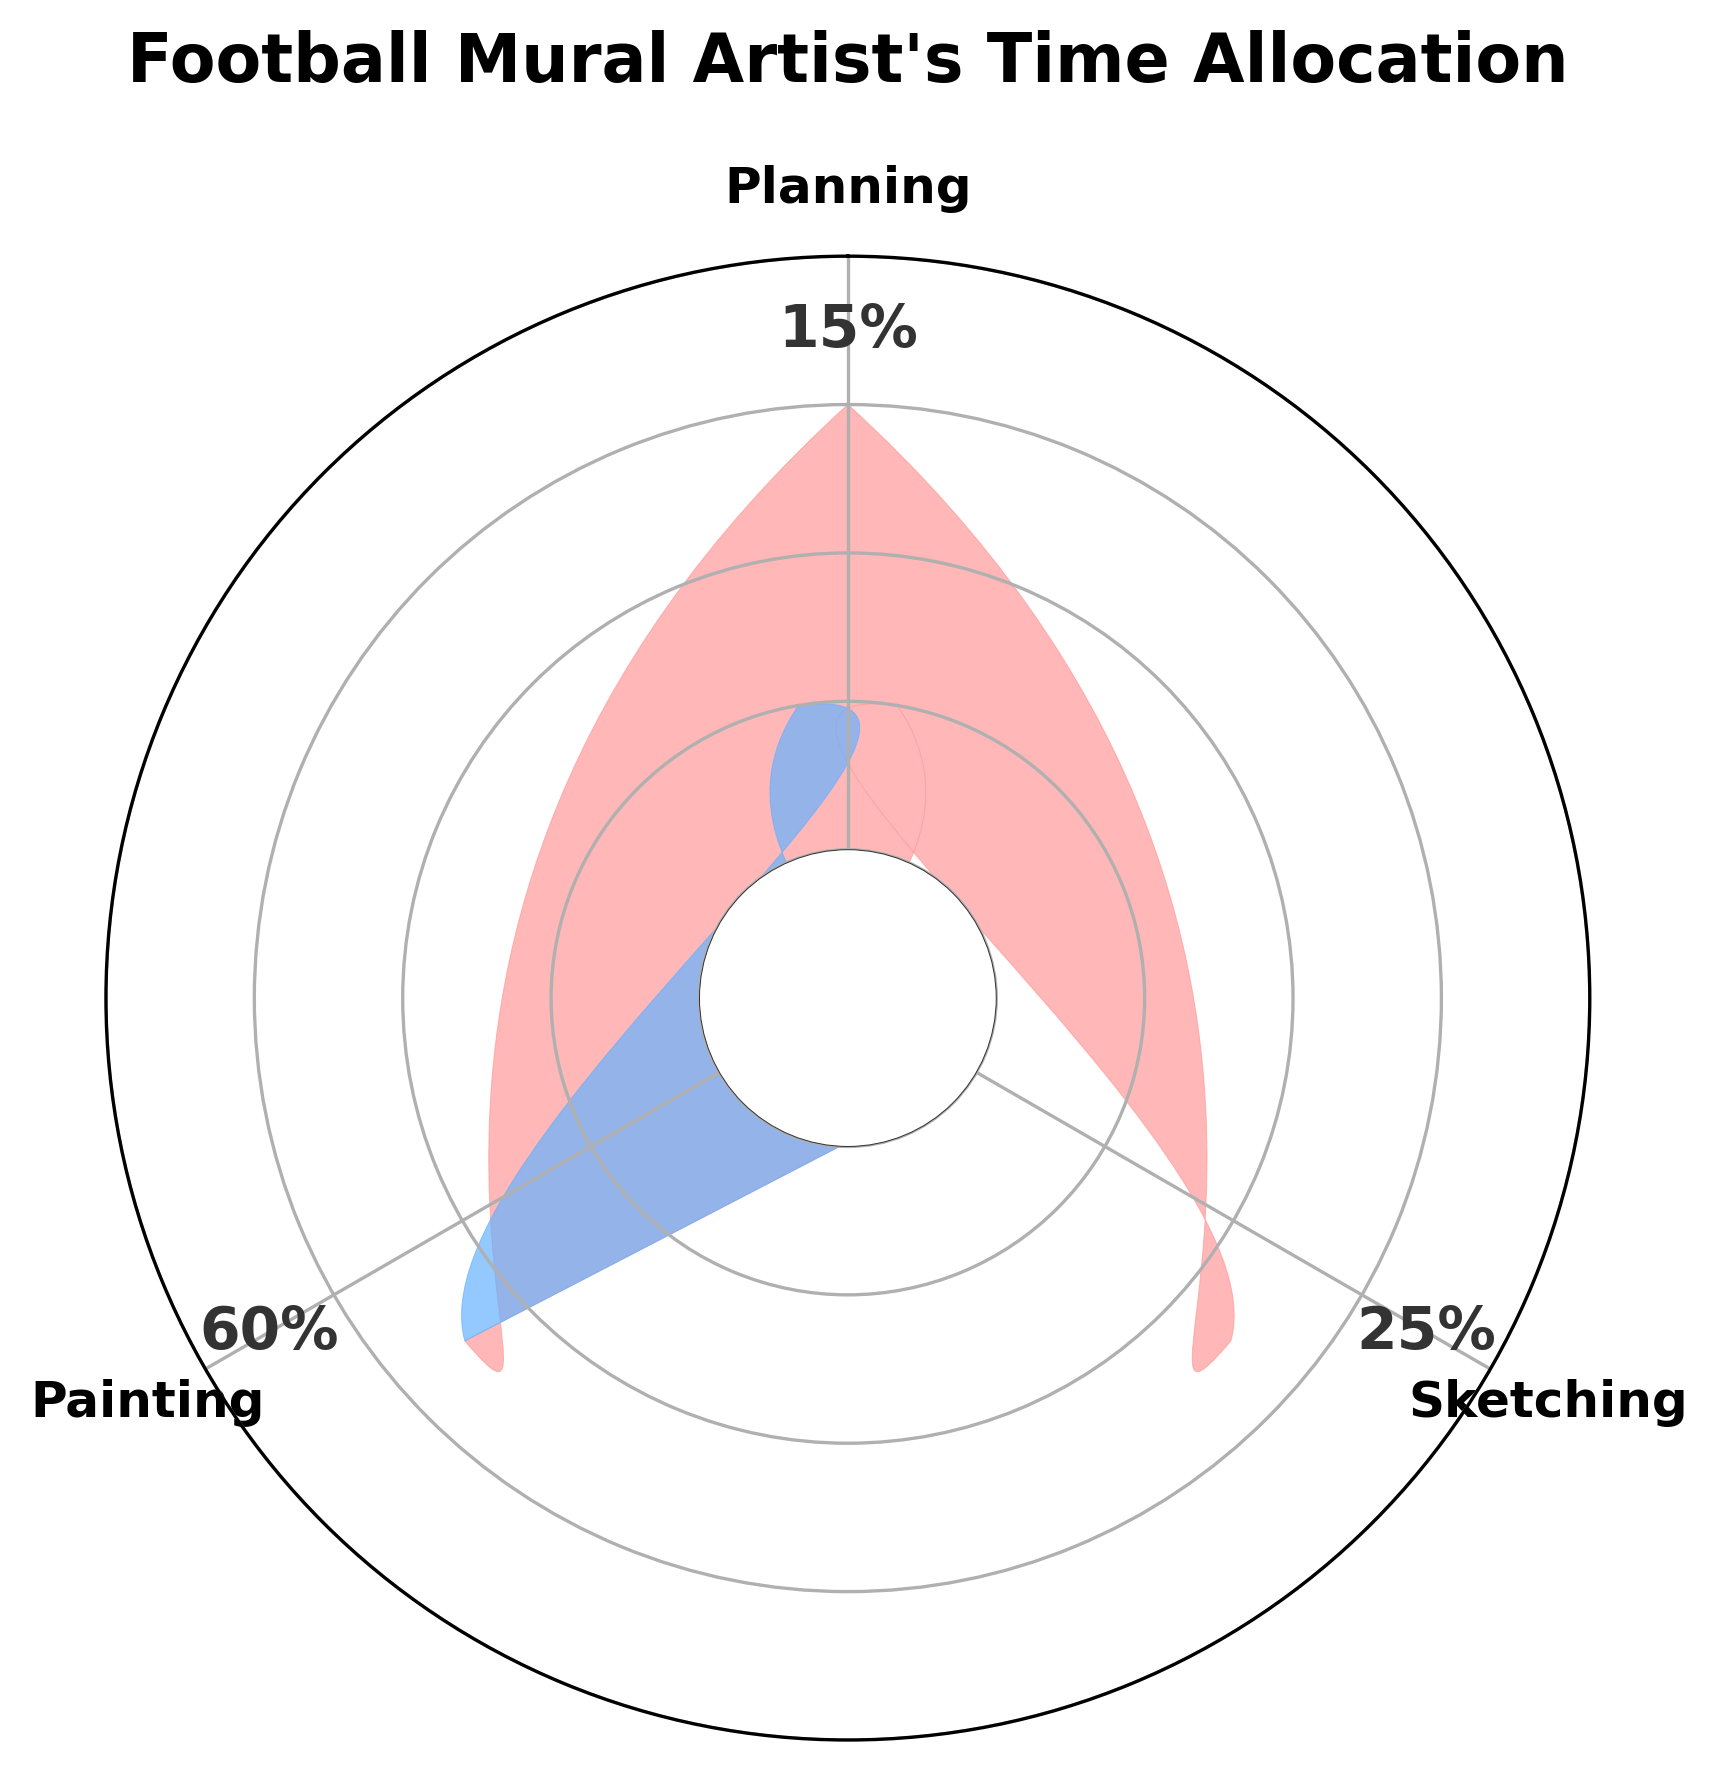What is the title of the chart? The title of the chart is usually displayed prominently at the top. In this case, it is "Football Mural Artist's Time Allocation".
Answer: Football Mural Artist's Time Allocation Which activity takes up the most time according to the chart? The chart shows different activities and their corresponding percentages. The activity with the highest percentage is "Painting" at 60%.
Answer: Painting What percentage of time is allocated to sketching? The chart has percentages labeled around its outer circle. According to the labels, sketching takes up 25% of the time.
Answer: 25% What is the combined percentage of time spent on planning and sketching? By combining the percentages of time for planning (15%) and sketching (25%), we get 15 + 25 = 40%.
Answer: 40% Which activity takes less time than sketching but more time than painting? Sketching takes 25% of the time, and painting takes 60% of the time. The only other activity is planning, which takes 15% of the time and is less than 25% but more than 60%.
Answer: None How many activities are displayed in the chart? The activities are listed around the circle. By counting these labels, we can see there are three activities displayed.
Answer: 3 What is the difference in time allocation between painting and sketching? The percentage for painting is 60% and for sketching is 25%. Subtracting the two gives 60 - 25 = 35%.
Answer: 35% Which color represents the activity with the smallest time allocation? By looking at the colors corresponding to each activity, the smallest time allocation is 15% for Planning, which is typically colored in the chart.
Answer: The color associated with the 15% segment What is the average time allocated to each activity? Sum the percentages of all activities (15 + 25 + 60 = 100) and divide by the number of activities (3). The average is 100 / 3 ≈ 33.33%.
Answer: 33.33% Is the time spent on painting more than half of the total time? Painting is allocated 60% of the time, which is more than half of 100%, which is 50%.
Answer: Yes 